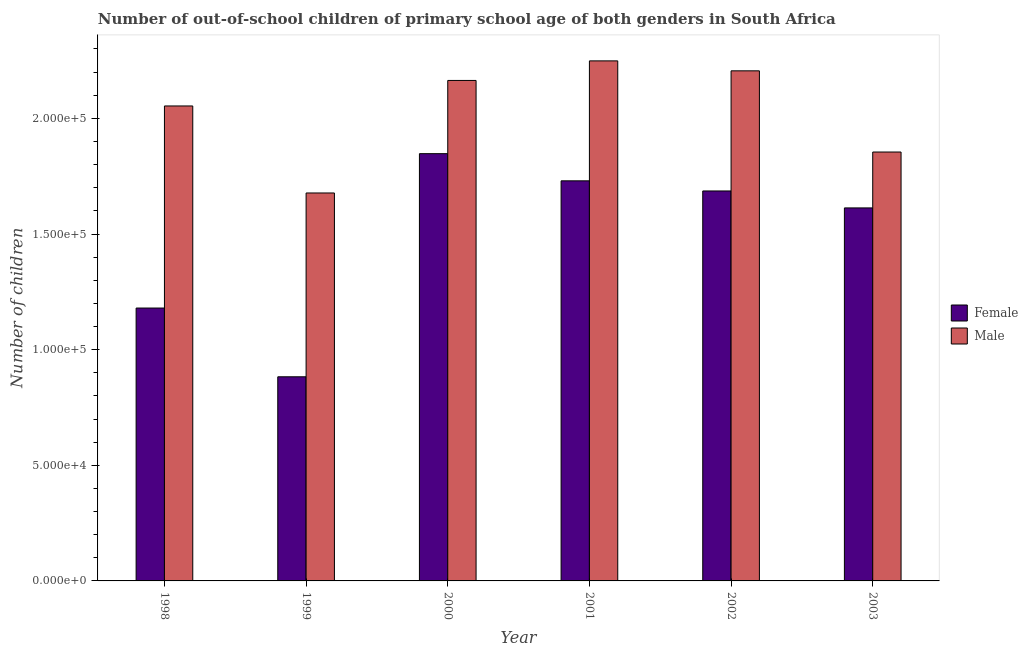What is the number of male out-of-school students in 1999?
Provide a short and direct response. 1.68e+05. Across all years, what is the maximum number of male out-of-school students?
Give a very brief answer. 2.25e+05. Across all years, what is the minimum number of male out-of-school students?
Offer a terse response. 1.68e+05. What is the total number of female out-of-school students in the graph?
Keep it short and to the point. 8.94e+05. What is the difference between the number of female out-of-school students in 1998 and that in 1999?
Offer a very short reply. 2.97e+04. What is the difference between the number of female out-of-school students in 2001 and the number of male out-of-school students in 2002?
Provide a succinct answer. 4384. What is the average number of female out-of-school students per year?
Your answer should be very brief. 1.49e+05. What is the ratio of the number of female out-of-school students in 1998 to that in 2003?
Your response must be concise. 0.73. Is the number of male out-of-school students in 2002 less than that in 2003?
Your response must be concise. No. Is the difference between the number of male out-of-school students in 1998 and 2001 greater than the difference between the number of female out-of-school students in 1998 and 2001?
Give a very brief answer. No. What is the difference between the highest and the second highest number of female out-of-school students?
Offer a very short reply. 1.17e+04. What is the difference between the highest and the lowest number of female out-of-school students?
Offer a terse response. 9.65e+04. What does the 2nd bar from the left in 2002 represents?
Provide a short and direct response. Male. How many years are there in the graph?
Your answer should be compact. 6. Does the graph contain any zero values?
Provide a short and direct response. No. How are the legend labels stacked?
Make the answer very short. Vertical. What is the title of the graph?
Ensure brevity in your answer.  Number of out-of-school children of primary school age of both genders in South Africa. What is the label or title of the Y-axis?
Your answer should be compact. Number of children. What is the Number of children of Female in 1998?
Provide a short and direct response. 1.18e+05. What is the Number of children of Male in 1998?
Give a very brief answer. 2.05e+05. What is the Number of children of Female in 1999?
Give a very brief answer. 8.83e+04. What is the Number of children in Male in 1999?
Offer a very short reply. 1.68e+05. What is the Number of children of Female in 2000?
Your response must be concise. 1.85e+05. What is the Number of children of Male in 2000?
Ensure brevity in your answer.  2.16e+05. What is the Number of children in Female in 2001?
Ensure brevity in your answer.  1.73e+05. What is the Number of children in Male in 2001?
Ensure brevity in your answer.  2.25e+05. What is the Number of children of Female in 2002?
Your answer should be compact. 1.69e+05. What is the Number of children of Male in 2002?
Give a very brief answer. 2.21e+05. What is the Number of children in Female in 2003?
Your answer should be very brief. 1.61e+05. What is the Number of children of Male in 2003?
Your response must be concise. 1.85e+05. Across all years, what is the maximum Number of children of Female?
Your answer should be very brief. 1.85e+05. Across all years, what is the maximum Number of children in Male?
Keep it short and to the point. 2.25e+05. Across all years, what is the minimum Number of children in Female?
Your response must be concise. 8.83e+04. Across all years, what is the minimum Number of children in Male?
Offer a terse response. 1.68e+05. What is the total Number of children of Female in the graph?
Offer a terse response. 8.94e+05. What is the total Number of children of Male in the graph?
Keep it short and to the point. 1.22e+06. What is the difference between the Number of children of Female in 1998 and that in 1999?
Offer a terse response. 2.97e+04. What is the difference between the Number of children in Male in 1998 and that in 1999?
Ensure brevity in your answer.  3.76e+04. What is the difference between the Number of children in Female in 1998 and that in 2000?
Offer a terse response. -6.67e+04. What is the difference between the Number of children in Male in 1998 and that in 2000?
Offer a terse response. -1.10e+04. What is the difference between the Number of children in Female in 1998 and that in 2001?
Your response must be concise. -5.50e+04. What is the difference between the Number of children of Male in 1998 and that in 2001?
Offer a terse response. -1.95e+04. What is the difference between the Number of children in Female in 1998 and that in 2002?
Provide a succinct answer. -5.06e+04. What is the difference between the Number of children of Male in 1998 and that in 2002?
Provide a succinct answer. -1.52e+04. What is the difference between the Number of children in Female in 1998 and that in 2003?
Your response must be concise. -4.33e+04. What is the difference between the Number of children in Male in 1998 and that in 2003?
Make the answer very short. 1.99e+04. What is the difference between the Number of children in Female in 1999 and that in 2000?
Keep it short and to the point. -9.65e+04. What is the difference between the Number of children in Male in 1999 and that in 2000?
Offer a terse response. -4.87e+04. What is the difference between the Number of children of Female in 1999 and that in 2001?
Provide a succinct answer. -8.47e+04. What is the difference between the Number of children of Male in 1999 and that in 2001?
Your answer should be compact. -5.71e+04. What is the difference between the Number of children of Female in 1999 and that in 2002?
Your answer should be very brief. -8.03e+04. What is the difference between the Number of children of Male in 1999 and that in 2002?
Make the answer very short. -5.28e+04. What is the difference between the Number of children in Female in 1999 and that in 2003?
Your answer should be compact. -7.30e+04. What is the difference between the Number of children of Male in 1999 and that in 2003?
Your answer should be compact. -1.77e+04. What is the difference between the Number of children in Female in 2000 and that in 2001?
Provide a short and direct response. 1.17e+04. What is the difference between the Number of children in Male in 2000 and that in 2001?
Offer a very short reply. -8460. What is the difference between the Number of children in Female in 2000 and that in 2002?
Your answer should be very brief. 1.61e+04. What is the difference between the Number of children of Male in 2000 and that in 2002?
Ensure brevity in your answer.  -4153. What is the difference between the Number of children of Female in 2000 and that in 2003?
Your answer should be compact. 2.35e+04. What is the difference between the Number of children of Male in 2000 and that in 2003?
Offer a very short reply. 3.09e+04. What is the difference between the Number of children in Female in 2001 and that in 2002?
Your answer should be very brief. 4384. What is the difference between the Number of children in Male in 2001 and that in 2002?
Offer a very short reply. 4307. What is the difference between the Number of children in Female in 2001 and that in 2003?
Make the answer very short. 1.17e+04. What is the difference between the Number of children in Male in 2001 and that in 2003?
Provide a succinct answer. 3.94e+04. What is the difference between the Number of children of Female in 2002 and that in 2003?
Your answer should be very brief. 7328. What is the difference between the Number of children in Male in 2002 and that in 2003?
Ensure brevity in your answer.  3.51e+04. What is the difference between the Number of children in Female in 1998 and the Number of children in Male in 1999?
Offer a very short reply. -4.97e+04. What is the difference between the Number of children of Female in 1998 and the Number of children of Male in 2000?
Your answer should be compact. -9.84e+04. What is the difference between the Number of children of Female in 1998 and the Number of children of Male in 2001?
Your answer should be very brief. -1.07e+05. What is the difference between the Number of children in Female in 1998 and the Number of children in Male in 2002?
Provide a short and direct response. -1.03e+05. What is the difference between the Number of children of Female in 1998 and the Number of children of Male in 2003?
Provide a short and direct response. -6.75e+04. What is the difference between the Number of children in Female in 1999 and the Number of children in Male in 2000?
Keep it short and to the point. -1.28e+05. What is the difference between the Number of children of Female in 1999 and the Number of children of Male in 2001?
Your response must be concise. -1.37e+05. What is the difference between the Number of children in Female in 1999 and the Number of children in Male in 2002?
Your answer should be compact. -1.32e+05. What is the difference between the Number of children in Female in 1999 and the Number of children in Male in 2003?
Your answer should be compact. -9.72e+04. What is the difference between the Number of children of Female in 2000 and the Number of children of Male in 2001?
Provide a short and direct response. -4.01e+04. What is the difference between the Number of children of Female in 2000 and the Number of children of Male in 2002?
Ensure brevity in your answer.  -3.58e+04. What is the difference between the Number of children of Female in 2000 and the Number of children of Male in 2003?
Offer a terse response. -712. What is the difference between the Number of children in Female in 2001 and the Number of children in Male in 2002?
Ensure brevity in your answer.  -4.76e+04. What is the difference between the Number of children in Female in 2001 and the Number of children in Male in 2003?
Offer a very short reply. -1.25e+04. What is the difference between the Number of children in Female in 2002 and the Number of children in Male in 2003?
Your answer should be very brief. -1.68e+04. What is the average Number of children in Female per year?
Give a very brief answer. 1.49e+05. What is the average Number of children in Male per year?
Ensure brevity in your answer.  2.03e+05. In the year 1998, what is the difference between the Number of children of Female and Number of children of Male?
Give a very brief answer. -8.74e+04. In the year 1999, what is the difference between the Number of children in Female and Number of children in Male?
Your response must be concise. -7.95e+04. In the year 2000, what is the difference between the Number of children in Female and Number of children in Male?
Offer a very short reply. -3.17e+04. In the year 2001, what is the difference between the Number of children in Female and Number of children in Male?
Provide a short and direct response. -5.19e+04. In the year 2002, what is the difference between the Number of children of Female and Number of children of Male?
Give a very brief answer. -5.19e+04. In the year 2003, what is the difference between the Number of children in Female and Number of children in Male?
Ensure brevity in your answer.  -2.42e+04. What is the ratio of the Number of children in Female in 1998 to that in 1999?
Ensure brevity in your answer.  1.34. What is the ratio of the Number of children of Male in 1998 to that in 1999?
Ensure brevity in your answer.  1.22. What is the ratio of the Number of children in Female in 1998 to that in 2000?
Offer a terse response. 0.64. What is the ratio of the Number of children in Male in 1998 to that in 2000?
Offer a terse response. 0.95. What is the ratio of the Number of children in Female in 1998 to that in 2001?
Provide a short and direct response. 0.68. What is the ratio of the Number of children in Male in 1998 to that in 2001?
Provide a short and direct response. 0.91. What is the ratio of the Number of children in Female in 1998 to that in 2002?
Offer a very short reply. 0.7. What is the ratio of the Number of children of Male in 1998 to that in 2002?
Ensure brevity in your answer.  0.93. What is the ratio of the Number of children in Female in 1998 to that in 2003?
Give a very brief answer. 0.73. What is the ratio of the Number of children in Male in 1998 to that in 2003?
Your response must be concise. 1.11. What is the ratio of the Number of children of Female in 1999 to that in 2000?
Make the answer very short. 0.48. What is the ratio of the Number of children of Male in 1999 to that in 2000?
Your answer should be compact. 0.78. What is the ratio of the Number of children of Female in 1999 to that in 2001?
Offer a terse response. 0.51. What is the ratio of the Number of children of Male in 1999 to that in 2001?
Give a very brief answer. 0.75. What is the ratio of the Number of children of Female in 1999 to that in 2002?
Give a very brief answer. 0.52. What is the ratio of the Number of children of Male in 1999 to that in 2002?
Offer a terse response. 0.76. What is the ratio of the Number of children in Female in 1999 to that in 2003?
Provide a succinct answer. 0.55. What is the ratio of the Number of children in Male in 1999 to that in 2003?
Offer a very short reply. 0.9. What is the ratio of the Number of children of Female in 2000 to that in 2001?
Offer a terse response. 1.07. What is the ratio of the Number of children of Male in 2000 to that in 2001?
Offer a very short reply. 0.96. What is the ratio of the Number of children of Female in 2000 to that in 2002?
Keep it short and to the point. 1.1. What is the ratio of the Number of children of Male in 2000 to that in 2002?
Your response must be concise. 0.98. What is the ratio of the Number of children of Female in 2000 to that in 2003?
Offer a terse response. 1.15. What is the ratio of the Number of children of Male in 2000 to that in 2003?
Provide a short and direct response. 1.17. What is the ratio of the Number of children of Male in 2001 to that in 2002?
Provide a short and direct response. 1.02. What is the ratio of the Number of children in Female in 2001 to that in 2003?
Offer a terse response. 1.07. What is the ratio of the Number of children of Male in 2001 to that in 2003?
Your answer should be compact. 1.21. What is the ratio of the Number of children in Female in 2002 to that in 2003?
Make the answer very short. 1.05. What is the ratio of the Number of children in Male in 2002 to that in 2003?
Give a very brief answer. 1.19. What is the difference between the highest and the second highest Number of children of Female?
Offer a terse response. 1.17e+04. What is the difference between the highest and the second highest Number of children of Male?
Ensure brevity in your answer.  4307. What is the difference between the highest and the lowest Number of children in Female?
Keep it short and to the point. 9.65e+04. What is the difference between the highest and the lowest Number of children of Male?
Your response must be concise. 5.71e+04. 